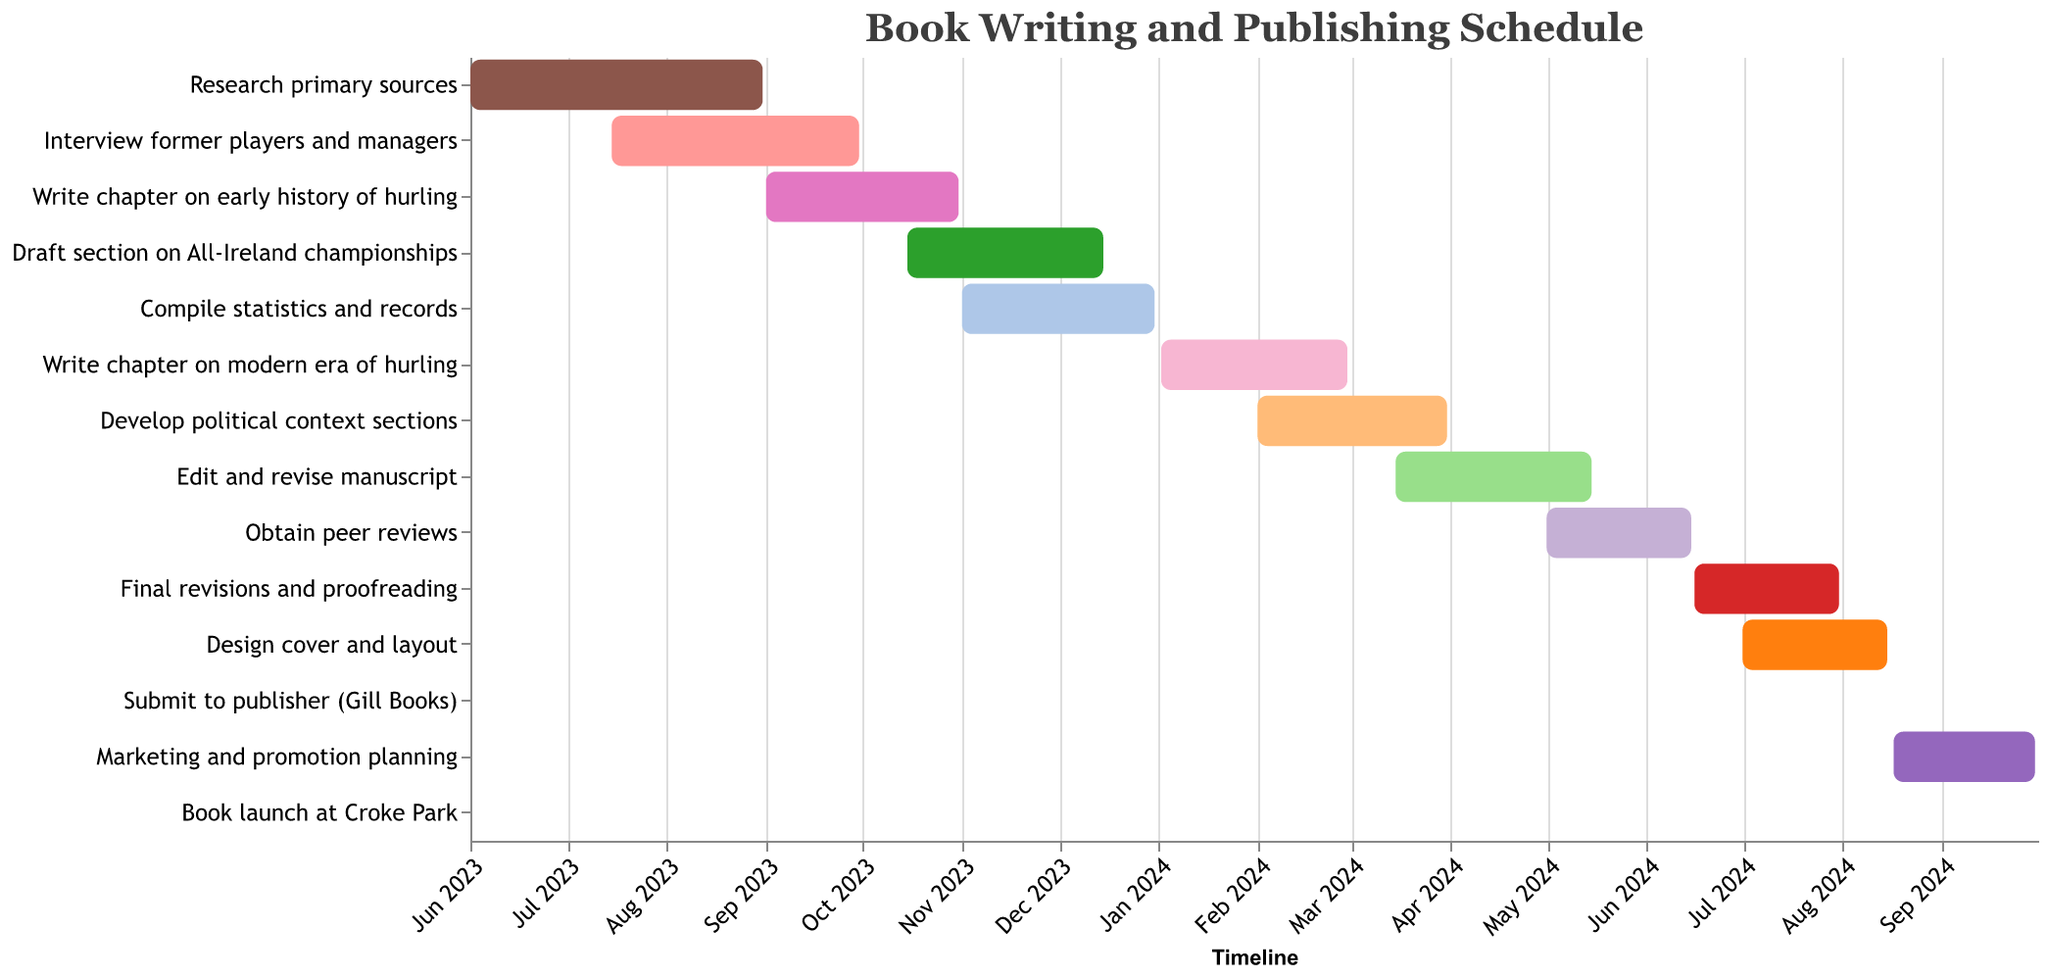What's the title of the Gantt chart? The title is located at the top of the chart where it provides an overview of the chart's content. By reading the title, "Book Writing and Publishing Schedule", we can understand what the Gantt chart is about.
Answer: Book Writing and Publishing Schedule When does the task "Research primary sources" start and end? To identify the start and end dates of the "Research primary sources" task, locate it on the vertical axis, then look across to the horizontal axis where the start and end points of its bar are indicated.
Answer: June 1, 2023 - August 31, 2023 How long does the task "Edit and revise manuscript" take? To determine the duration of the "Edit and revise manuscript" task, find the task on the vertical axis, then calculate the time difference between its start date (March 15, 2024) and end date (May 15, 2024).
Answer: 2 months Which tasks overlap with "Interview former players and managers"? To find overlapping tasks, identify the duration of "Interview former players and managers" (July 15, 2023 - September 30, 2023) and check which other tasks have bars that intersect this timespan. These include "Research primary sources", and "Write chapter on early history of hurling".
Answer: Research primary sources, Write chapter on early history of hurling Which task has the shortest duration? To determine the shortest task, compare the lengths of all task bars. The "Submit to publisher (Gill Books)" has the shortest duration as it starts and ends on the same day, August 16, 2024.
Answer: Submit to publisher (Gill Books) What is the last task scheduled before the book launch? Identify the book launch task on October 1, 2024, then look for the task scheduled just before it. "Marketing and promotion planning" ends on September 30, 2024, right before the book launch.
Answer: Marketing and promotion planning How many tasks are scheduled to start in 2023? Count the number of tasks whose start dates fall within 2023 by examining the horizontal timeline and the corresponding task start points. There are 5 tasks starting in 2023: "Research primary sources", "Interview former players and managers", "Write chapter on early history of hurling", "Draft section on All-Ireland championships", and "Compile statistics and records".
Answer: 5 tasks Which task involves activities related to political context? Look for the task description that includes political context. The task "Develop political context sections" fits this criterion.
Answer: Develop political context sections What is the longest task, and how long is it? Measure the lengths of all task bars and identify the longest one. The task "Final revisions and proofreading" lasts from June 16, 2024, to July 31, 2024, which is about 1.5 months.
Answer: Final revisions and proofreading, 1.5 months When does the task for designing the cover and layout take place, and how does it overlap with other tasks? Find the "Design cover and layout" task (July 1, 2024 - August 15, 2024) and examine the timeline to see which tasks are active during these dates. It overlaps with "Final revisions and proofreading" and the start of "Submit to publisher (Gill Books)".
Answer: July 1, 2024 - August 15, 2024, overlaps with Final revisions and proofreading and Submit to publisher (Gill Books) 